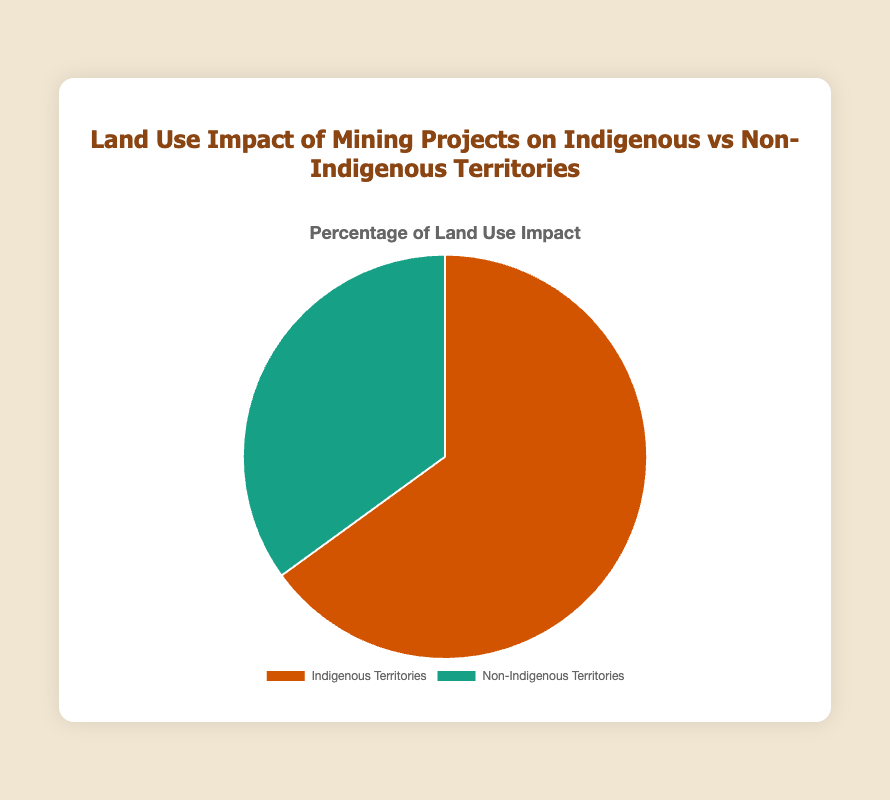what percentage of land use impact is on indigenous territories? The figure shows a pie chart with two segments: one for Indigenous Territories and another for Non-Indigenous Territories. The segment for Indigenous Territories is labeled with a value of 65%.
Answer: 65% what percentage of land use impact is on non-indigenous territories? The pie chart displays a segment for Non-Indigenous Territories labeled with a value of 35%.
Answer: 35% which type of territory has a greater impact on land use? To determine which type of territory has a greater impact, compare the percentages. Indigenous Territories have a 65% impact, while Non-Indigenous Territories have a 35% impact. 65% is greater than 35%.
Answer: Indigenous Territories how much greater is the land use impact on indigenous territories compared to non-indigenous territories? To find out how much greater the impact is, subtract the percentage impact on Non-Indigenous Territories from the percentage impact on Indigenous Territories. 65% - 35% = 30%.
Answer: 30% if the total land use impact is divided equally, what would be the new percentage for each territory? If the total impact (100%) is divided equally between the two territories, each would receive 50%. Calculate 100% divided by 2.
Answer: 50% what is the ratio of land use impact between indigenous and non-indigenous territories? The ratio is found by dividing the percentage of land use impact on Indigenous Territories by the percentage on Non-Indigenous Territories. 65% divided by 35% simplifies to approximately 1.86.
Answer: 1.86:1 what fraction of the total land use impact is on non-indigenous territories? The percentage impact on Non-Indigenous Territories is 35%. To convert this to a fraction, divide by 100. 35/100 simplifies to 7/20.
Answer: 7/20 what color represents the land use impact on indigenous territories in the pie chart? Looking at the pie chart, the segment representing Indigenous Territories is shaded in a shade of brown.
Answer: Brown if the land use impact on non-indigenous territories increased by 10%, what would be the new percentage for indigenous territories? If the impact on Non-Indigenous Territories increases by 10%, it becomes 35% + 10% = 45%. Since the total must be 100%, the new percentage for Indigenous Territories is 100% - 45% = 55%.
Answer: 55% how would the pie chart change if the percentages for both territories were swapped? If the percentages were swapped, Indigenous Territories would have 35% and Non-Indigenous Territories would have 65%. The visual segments of the pie chart would change, with the current larger segment reducing in size and the smaller segment increasing.
Answer: Indigenous Territories: 35%, Non-Indigenous Territories: 65% 